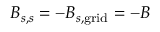<formula> <loc_0><loc_0><loc_500><loc_500>B _ { s , s } = - B _ { s , g r i d } = - B</formula> 